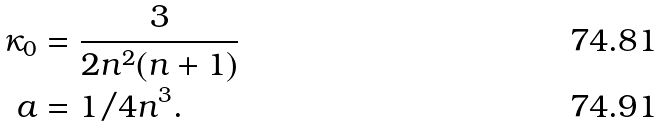<formula> <loc_0><loc_0><loc_500><loc_500>\kappa _ { 0 } & = \frac { 3 } { 2 n ^ { 2 } ( n + 1 ) } \\ a & = 1 / 4 n ^ { 3 } .</formula> 